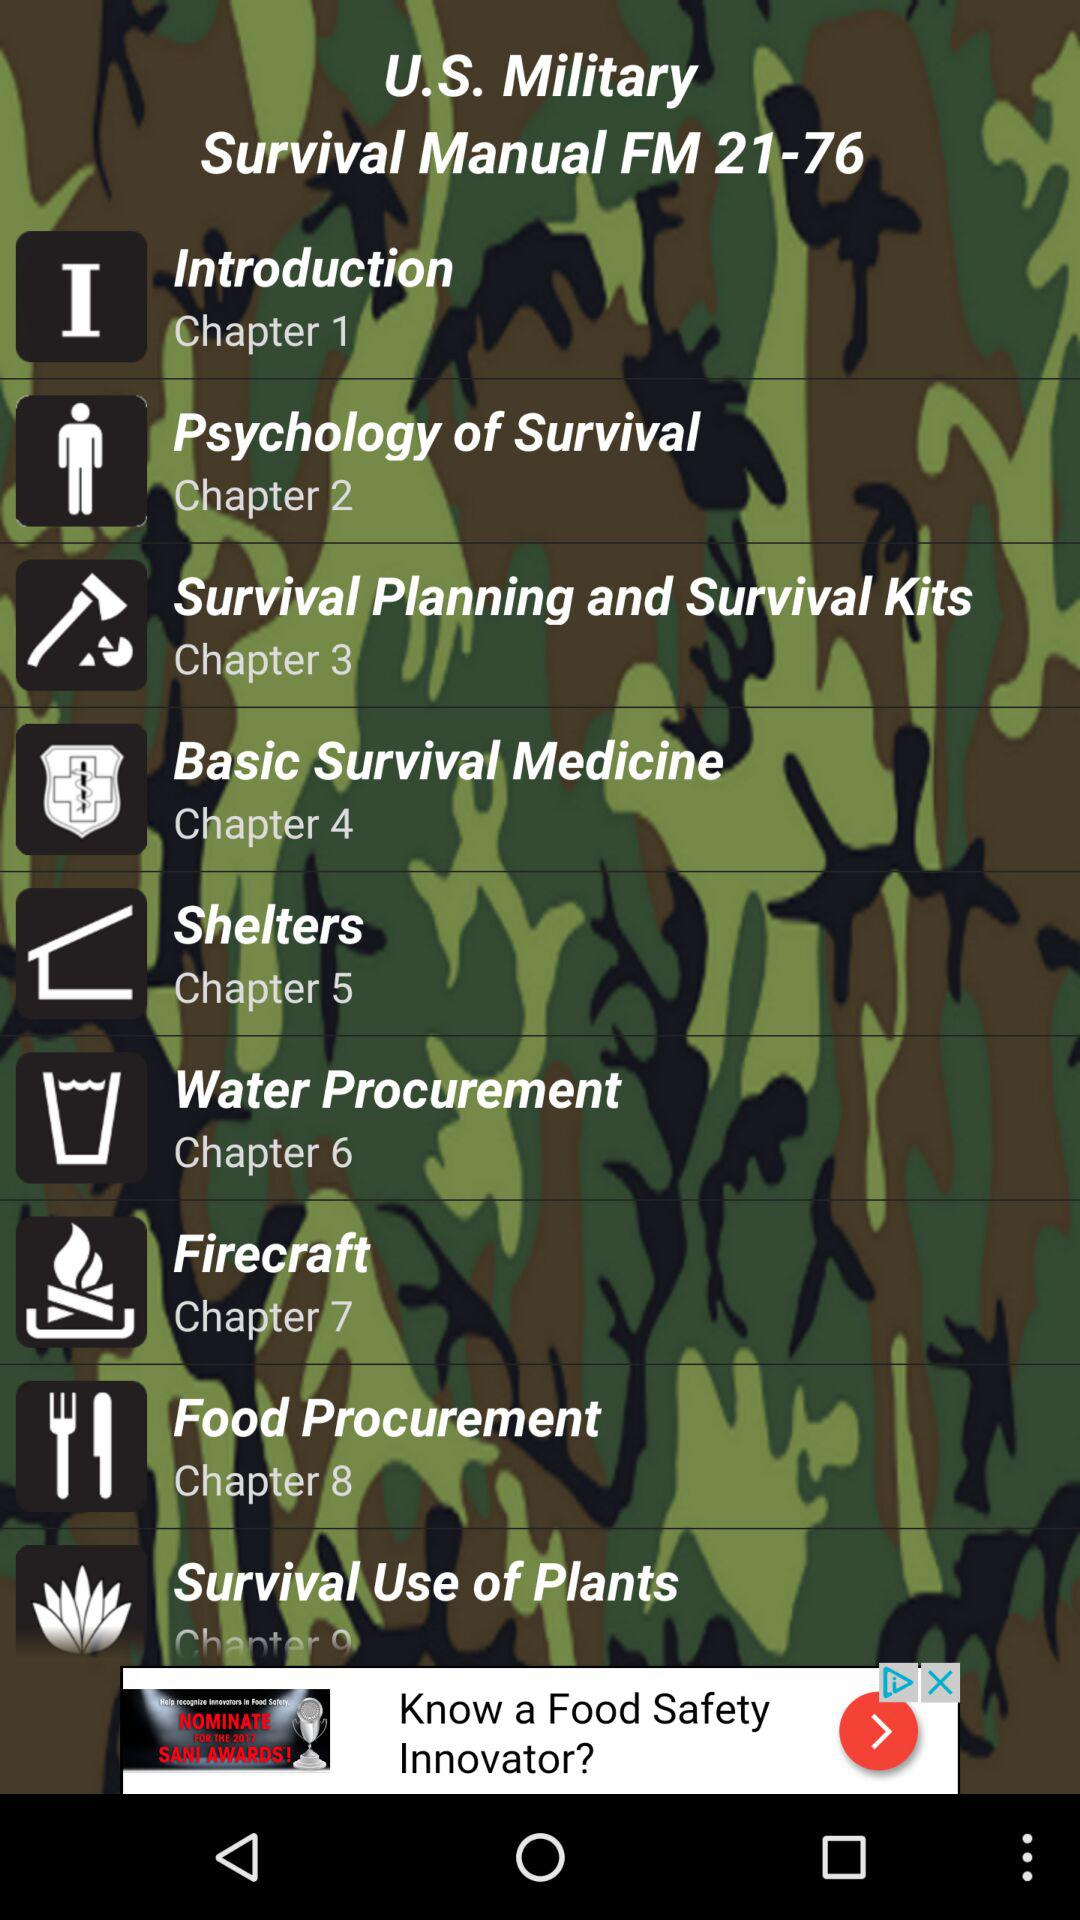What manual is this? This is a "Survival Manual FM 21-76". 